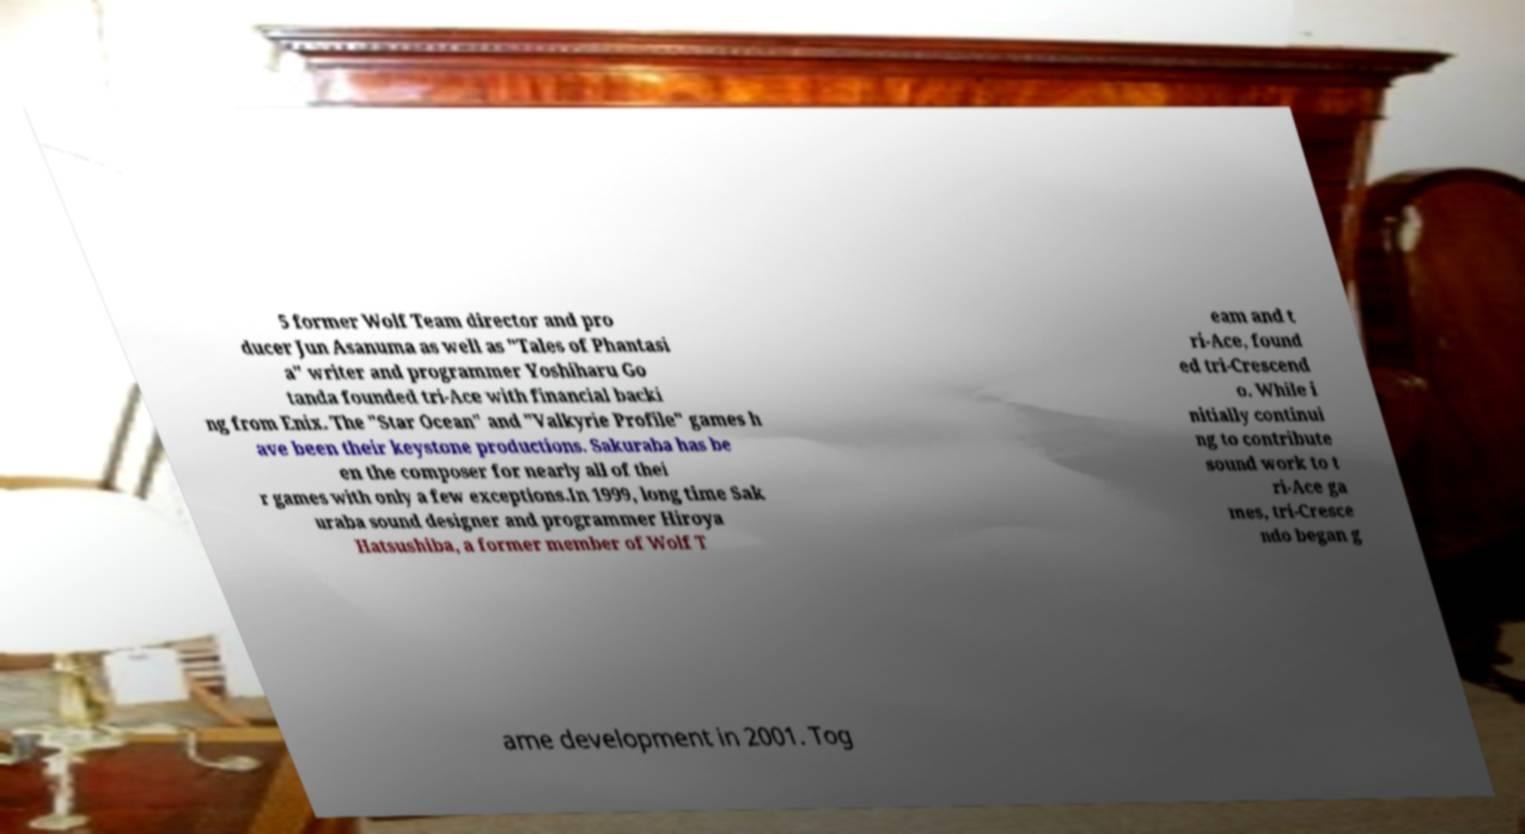Please read and relay the text visible in this image. What does it say? 5 former Wolf Team director and pro ducer Jun Asanuma as well as "Tales of Phantasi a" writer and programmer Yoshiharu Go tanda founded tri-Ace with financial backi ng from Enix. The "Star Ocean" and "Valkyrie Profile" games h ave been their keystone productions. Sakuraba has be en the composer for nearly all of thei r games with only a few exceptions.In 1999, long time Sak uraba sound designer and programmer Hiroya Hatsushiba, a former member of Wolf T eam and t ri-Ace, found ed tri-Crescend o. While i nitially continui ng to contribute sound work to t ri-Ace ga mes, tri-Cresce ndo began g ame development in 2001. Tog 